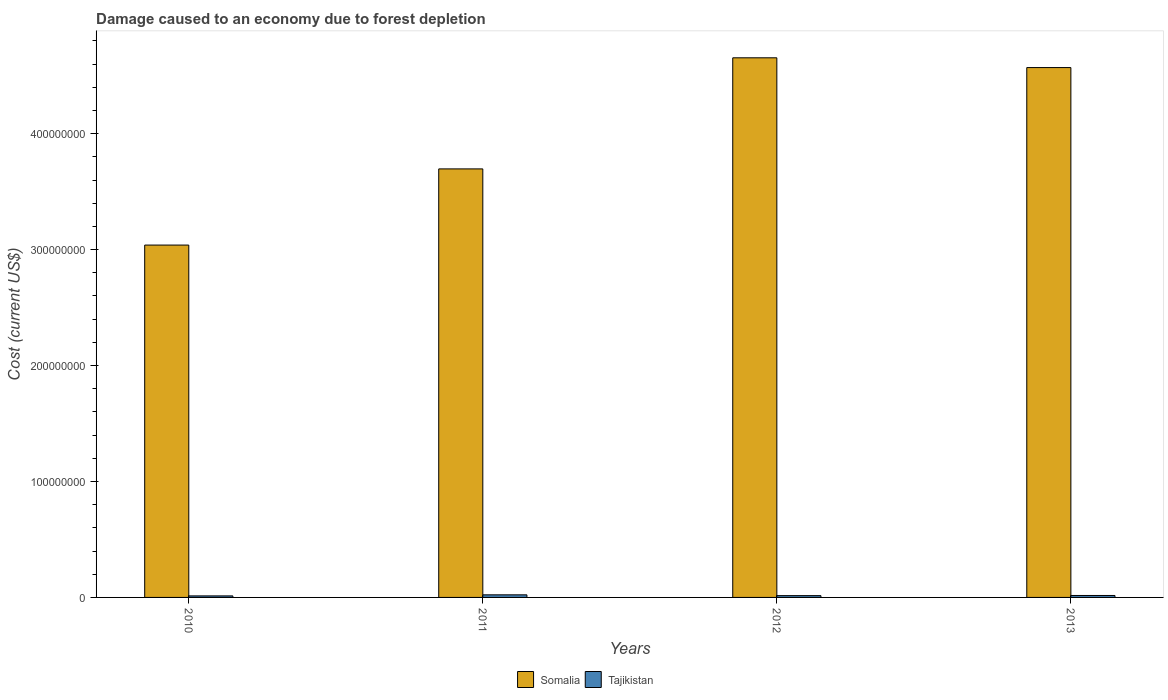How many different coloured bars are there?
Give a very brief answer. 2. Are the number of bars on each tick of the X-axis equal?
Offer a very short reply. Yes. How many bars are there on the 4th tick from the left?
Your response must be concise. 2. What is the label of the 3rd group of bars from the left?
Make the answer very short. 2012. In how many cases, is the number of bars for a given year not equal to the number of legend labels?
Your answer should be very brief. 0. What is the cost of damage caused due to forest depletion in Tajikistan in 2010?
Keep it short and to the point. 1.31e+06. Across all years, what is the maximum cost of damage caused due to forest depletion in Tajikistan?
Offer a very short reply. 2.23e+06. Across all years, what is the minimum cost of damage caused due to forest depletion in Tajikistan?
Keep it short and to the point. 1.31e+06. What is the total cost of damage caused due to forest depletion in Tajikistan in the graph?
Your response must be concise. 6.77e+06. What is the difference between the cost of damage caused due to forest depletion in Tajikistan in 2010 and that in 2013?
Provide a short and direct response. -3.72e+05. What is the difference between the cost of damage caused due to forest depletion in Tajikistan in 2011 and the cost of damage caused due to forest depletion in Somalia in 2012?
Ensure brevity in your answer.  -4.63e+08. What is the average cost of damage caused due to forest depletion in Tajikistan per year?
Keep it short and to the point. 1.69e+06. In the year 2011, what is the difference between the cost of damage caused due to forest depletion in Somalia and cost of damage caused due to forest depletion in Tajikistan?
Give a very brief answer. 3.67e+08. In how many years, is the cost of damage caused due to forest depletion in Tajikistan greater than 440000000 US$?
Make the answer very short. 0. What is the ratio of the cost of damage caused due to forest depletion in Somalia in 2010 to that in 2012?
Provide a succinct answer. 0.65. Is the cost of damage caused due to forest depletion in Somalia in 2011 less than that in 2012?
Give a very brief answer. Yes. What is the difference between the highest and the second highest cost of damage caused due to forest depletion in Somalia?
Make the answer very short. 8.42e+06. What is the difference between the highest and the lowest cost of damage caused due to forest depletion in Somalia?
Offer a terse response. 1.62e+08. In how many years, is the cost of damage caused due to forest depletion in Somalia greater than the average cost of damage caused due to forest depletion in Somalia taken over all years?
Offer a terse response. 2. What does the 1st bar from the left in 2013 represents?
Provide a succinct answer. Somalia. What does the 1st bar from the right in 2010 represents?
Keep it short and to the point. Tajikistan. How many bars are there?
Offer a terse response. 8. How many years are there in the graph?
Your response must be concise. 4. Does the graph contain any zero values?
Offer a terse response. No. Does the graph contain grids?
Provide a short and direct response. No. How many legend labels are there?
Provide a short and direct response. 2. How are the legend labels stacked?
Provide a succinct answer. Horizontal. What is the title of the graph?
Your answer should be very brief. Damage caused to an economy due to forest depletion. Does "Egypt, Arab Rep." appear as one of the legend labels in the graph?
Your answer should be compact. No. What is the label or title of the X-axis?
Offer a terse response. Years. What is the label or title of the Y-axis?
Provide a succinct answer. Cost (current US$). What is the Cost (current US$) in Somalia in 2010?
Keep it short and to the point. 3.04e+08. What is the Cost (current US$) in Tajikistan in 2010?
Provide a succinct answer. 1.31e+06. What is the Cost (current US$) of Somalia in 2011?
Your answer should be very brief. 3.70e+08. What is the Cost (current US$) in Tajikistan in 2011?
Provide a succinct answer. 2.23e+06. What is the Cost (current US$) in Somalia in 2012?
Your response must be concise. 4.65e+08. What is the Cost (current US$) of Tajikistan in 2012?
Offer a very short reply. 1.55e+06. What is the Cost (current US$) of Somalia in 2013?
Your answer should be compact. 4.57e+08. What is the Cost (current US$) in Tajikistan in 2013?
Your answer should be very brief. 1.69e+06. Across all years, what is the maximum Cost (current US$) in Somalia?
Offer a terse response. 4.65e+08. Across all years, what is the maximum Cost (current US$) in Tajikistan?
Your response must be concise. 2.23e+06. Across all years, what is the minimum Cost (current US$) in Somalia?
Offer a terse response. 3.04e+08. Across all years, what is the minimum Cost (current US$) of Tajikistan?
Make the answer very short. 1.31e+06. What is the total Cost (current US$) of Somalia in the graph?
Your answer should be very brief. 1.60e+09. What is the total Cost (current US$) in Tajikistan in the graph?
Ensure brevity in your answer.  6.77e+06. What is the difference between the Cost (current US$) of Somalia in 2010 and that in 2011?
Your answer should be very brief. -6.57e+07. What is the difference between the Cost (current US$) of Tajikistan in 2010 and that in 2011?
Your response must be concise. -9.15e+05. What is the difference between the Cost (current US$) in Somalia in 2010 and that in 2012?
Offer a very short reply. -1.62e+08. What is the difference between the Cost (current US$) of Tajikistan in 2010 and that in 2012?
Keep it short and to the point. -2.36e+05. What is the difference between the Cost (current US$) in Somalia in 2010 and that in 2013?
Your answer should be very brief. -1.53e+08. What is the difference between the Cost (current US$) in Tajikistan in 2010 and that in 2013?
Offer a very short reply. -3.72e+05. What is the difference between the Cost (current US$) in Somalia in 2011 and that in 2012?
Provide a short and direct response. -9.58e+07. What is the difference between the Cost (current US$) in Tajikistan in 2011 and that in 2012?
Ensure brevity in your answer.  6.79e+05. What is the difference between the Cost (current US$) in Somalia in 2011 and that in 2013?
Offer a terse response. -8.74e+07. What is the difference between the Cost (current US$) of Tajikistan in 2011 and that in 2013?
Keep it short and to the point. 5.43e+05. What is the difference between the Cost (current US$) in Somalia in 2012 and that in 2013?
Provide a succinct answer. 8.42e+06. What is the difference between the Cost (current US$) of Tajikistan in 2012 and that in 2013?
Give a very brief answer. -1.36e+05. What is the difference between the Cost (current US$) of Somalia in 2010 and the Cost (current US$) of Tajikistan in 2011?
Ensure brevity in your answer.  3.02e+08. What is the difference between the Cost (current US$) of Somalia in 2010 and the Cost (current US$) of Tajikistan in 2012?
Give a very brief answer. 3.02e+08. What is the difference between the Cost (current US$) of Somalia in 2010 and the Cost (current US$) of Tajikistan in 2013?
Make the answer very short. 3.02e+08. What is the difference between the Cost (current US$) in Somalia in 2011 and the Cost (current US$) in Tajikistan in 2012?
Provide a short and direct response. 3.68e+08. What is the difference between the Cost (current US$) in Somalia in 2011 and the Cost (current US$) in Tajikistan in 2013?
Your response must be concise. 3.68e+08. What is the difference between the Cost (current US$) in Somalia in 2012 and the Cost (current US$) in Tajikistan in 2013?
Your answer should be compact. 4.64e+08. What is the average Cost (current US$) in Somalia per year?
Keep it short and to the point. 3.99e+08. What is the average Cost (current US$) in Tajikistan per year?
Ensure brevity in your answer.  1.69e+06. In the year 2010, what is the difference between the Cost (current US$) of Somalia and Cost (current US$) of Tajikistan?
Provide a short and direct response. 3.03e+08. In the year 2011, what is the difference between the Cost (current US$) in Somalia and Cost (current US$) in Tajikistan?
Your answer should be very brief. 3.67e+08. In the year 2012, what is the difference between the Cost (current US$) of Somalia and Cost (current US$) of Tajikistan?
Your response must be concise. 4.64e+08. In the year 2013, what is the difference between the Cost (current US$) of Somalia and Cost (current US$) of Tajikistan?
Provide a succinct answer. 4.55e+08. What is the ratio of the Cost (current US$) of Somalia in 2010 to that in 2011?
Your answer should be compact. 0.82. What is the ratio of the Cost (current US$) of Tajikistan in 2010 to that in 2011?
Your response must be concise. 0.59. What is the ratio of the Cost (current US$) of Somalia in 2010 to that in 2012?
Provide a short and direct response. 0.65. What is the ratio of the Cost (current US$) in Tajikistan in 2010 to that in 2012?
Give a very brief answer. 0.85. What is the ratio of the Cost (current US$) of Somalia in 2010 to that in 2013?
Your answer should be very brief. 0.67. What is the ratio of the Cost (current US$) of Tajikistan in 2010 to that in 2013?
Your answer should be compact. 0.78. What is the ratio of the Cost (current US$) of Somalia in 2011 to that in 2012?
Make the answer very short. 0.79. What is the ratio of the Cost (current US$) of Tajikistan in 2011 to that in 2012?
Your response must be concise. 1.44. What is the ratio of the Cost (current US$) in Somalia in 2011 to that in 2013?
Provide a succinct answer. 0.81. What is the ratio of the Cost (current US$) in Tajikistan in 2011 to that in 2013?
Offer a terse response. 1.32. What is the ratio of the Cost (current US$) in Somalia in 2012 to that in 2013?
Provide a short and direct response. 1.02. What is the ratio of the Cost (current US$) of Tajikistan in 2012 to that in 2013?
Offer a very short reply. 0.92. What is the difference between the highest and the second highest Cost (current US$) of Somalia?
Offer a very short reply. 8.42e+06. What is the difference between the highest and the second highest Cost (current US$) in Tajikistan?
Your response must be concise. 5.43e+05. What is the difference between the highest and the lowest Cost (current US$) in Somalia?
Provide a succinct answer. 1.62e+08. What is the difference between the highest and the lowest Cost (current US$) in Tajikistan?
Give a very brief answer. 9.15e+05. 